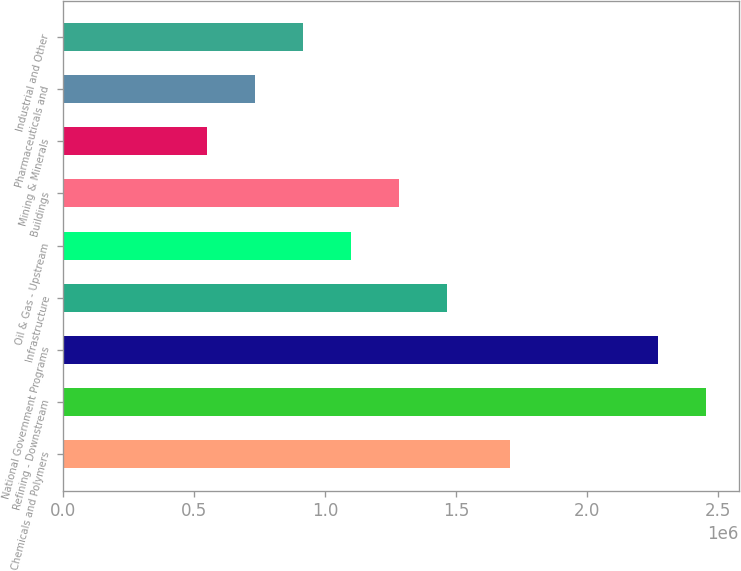<chart> <loc_0><loc_0><loc_500><loc_500><bar_chart><fcel>Chemicals and Polymers<fcel>Refining - Downstream<fcel>National Government Programs<fcel>Infrastructure<fcel>Oil & Gas - Upstream<fcel>Buildings<fcel>Mining & Minerals<fcel>Pharmaceuticals and<fcel>Industrial and Other<nl><fcel>1.70472e+06<fcel>2.45557e+06<fcel>2.27261e+06<fcel>1.46494e+06<fcel>1.09902e+06<fcel>1.28198e+06<fcel>550134<fcel>733096<fcel>916057<nl></chart> 